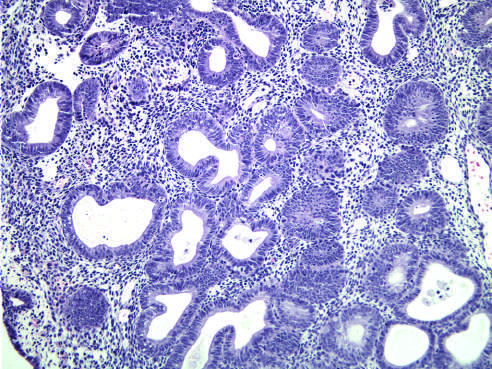what is characterized by nests of closely packed glands?
Answer the question using a single word or phrase. Hyperplasia without atypia 